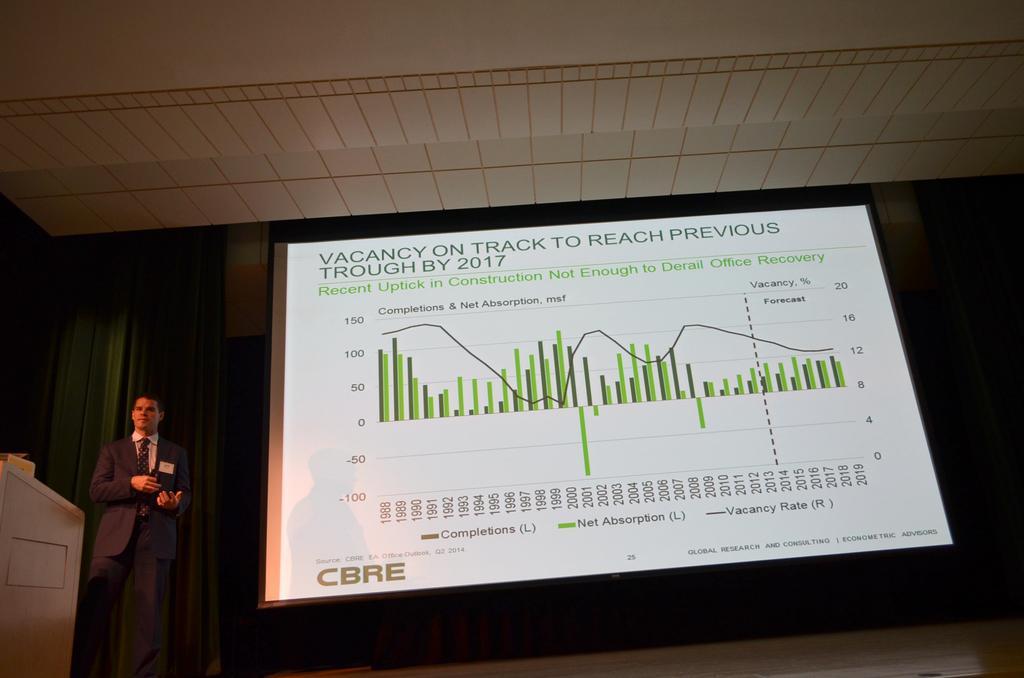Describe this image in one or two sentences. On the left side of the image we can see a man, he is standing, beside to him we can find a projector screen, in the background we can see curtains. 